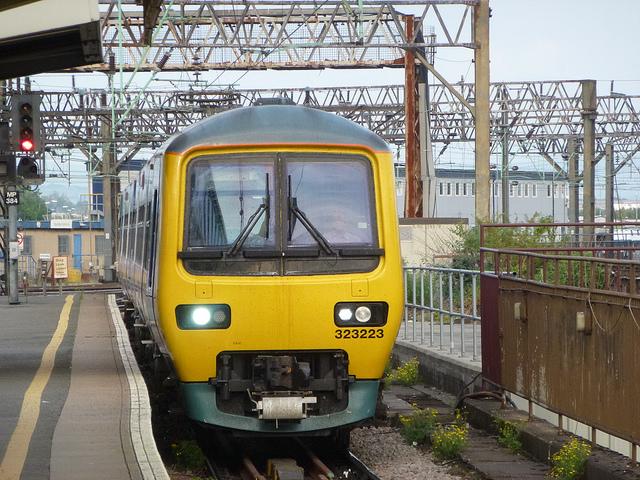What color is the train?
Keep it brief. Yellow. What are the numbers backwards?
Concise answer only. 322323. What is the number on the front of the train?
Answer briefly. 323223. 